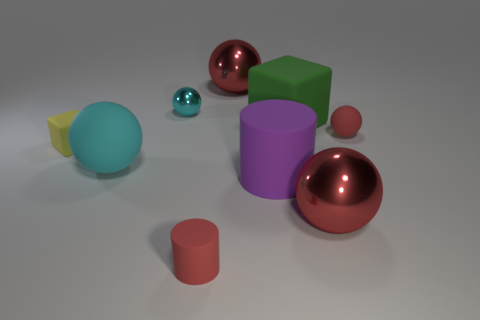What number of red spheres are there?
Ensure brevity in your answer.  3. Are there any cyan metal balls of the same size as the yellow block?
Provide a succinct answer. Yes. Are there fewer big balls that are right of the big purple matte cylinder than purple rubber cylinders?
Your response must be concise. No. Do the cyan rubber thing and the green cube have the same size?
Your answer should be compact. Yes. The red cylinder that is the same material as the big cyan object is what size?
Make the answer very short. Small. How many large shiny things have the same color as the small cylinder?
Offer a terse response. 2. Are there fewer red matte spheres that are on the left side of the tiny shiny thing than red shiny things in front of the big purple rubber cylinder?
Provide a succinct answer. Yes. Does the small red object that is on the right side of the purple thing have the same shape as the small cyan metallic object?
Your response must be concise. Yes. Is the cylinder that is behind the tiny red matte cylinder made of the same material as the big green thing?
Ensure brevity in your answer.  Yes. What material is the tiny sphere left of the red metal sphere that is behind the large red shiny object that is on the right side of the large green rubber block made of?
Ensure brevity in your answer.  Metal. 